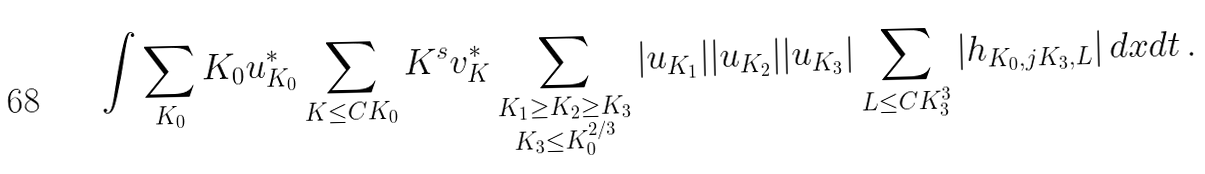<formula> <loc_0><loc_0><loc_500><loc_500>\int \sum _ { K _ { 0 } } K _ { 0 } u ^ { * } _ { K _ { 0 } } \sum _ { K \leq C K _ { 0 } } K ^ { s } { v } _ { K } ^ { * } \sum _ { \substack { K _ { 1 } \geq K _ { 2 } \geq K _ { 3 } \\ K _ { 3 } \leq K _ { 0 } ^ { 2 / 3 } } } | u _ { K _ { 1 } } | | u _ { K _ { 2 } } | | u _ { K _ { 3 } } | \sum _ { L \leq C K _ { 3 } ^ { 3 } } \left | h _ { K _ { 0 } , j K _ { 3 } , L } \right | d x d t \, .</formula> 